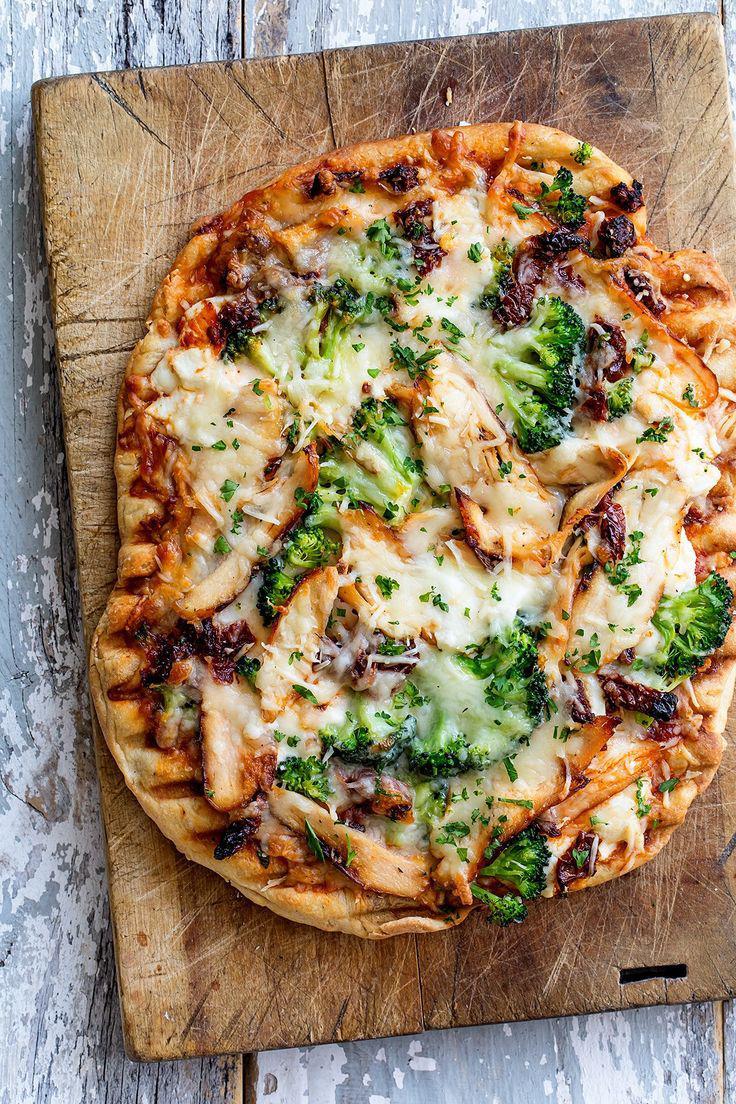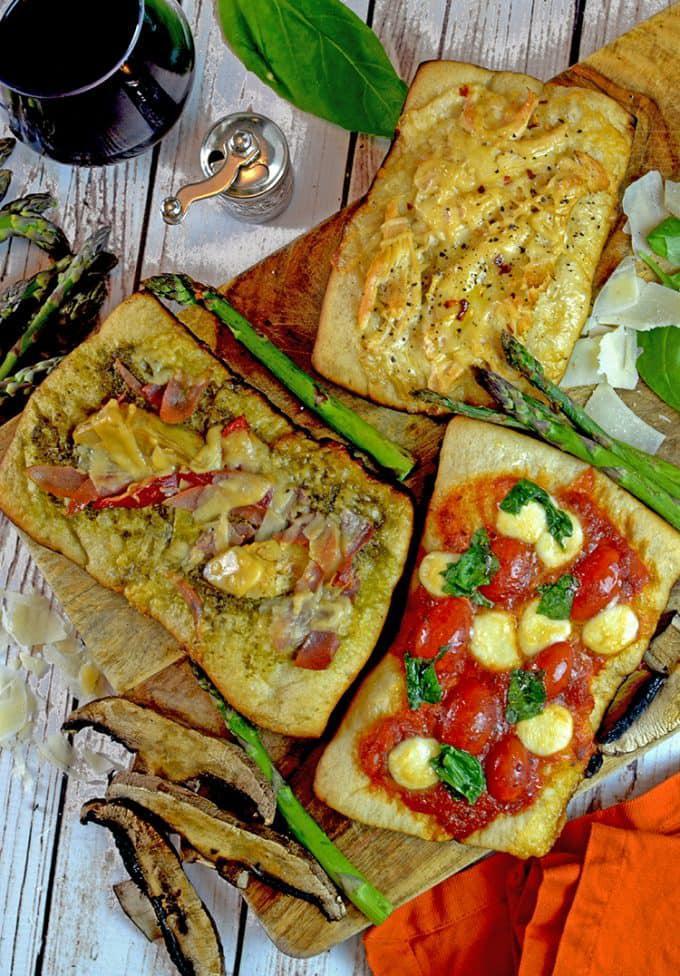The first image is the image on the left, the second image is the image on the right. Analyze the images presented: Is the assertion "Several pizzas sit on a rack in one of the images." valid? Answer yes or no. No. The first image is the image on the left, the second image is the image on the right. Assess this claim about the two images: "One image shows multiple round pizzas on a metal grating.". Correct or not? Answer yes or no. No. 